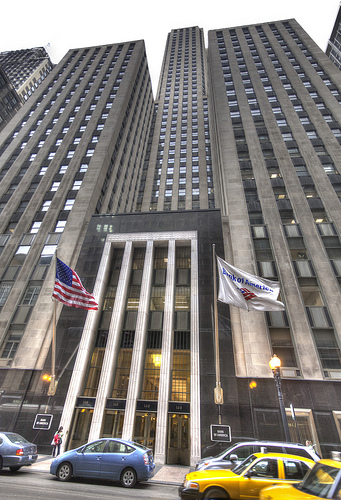<image>
Is the flag behind the building? No. The flag is not behind the building. From this viewpoint, the flag appears to be positioned elsewhere in the scene. 